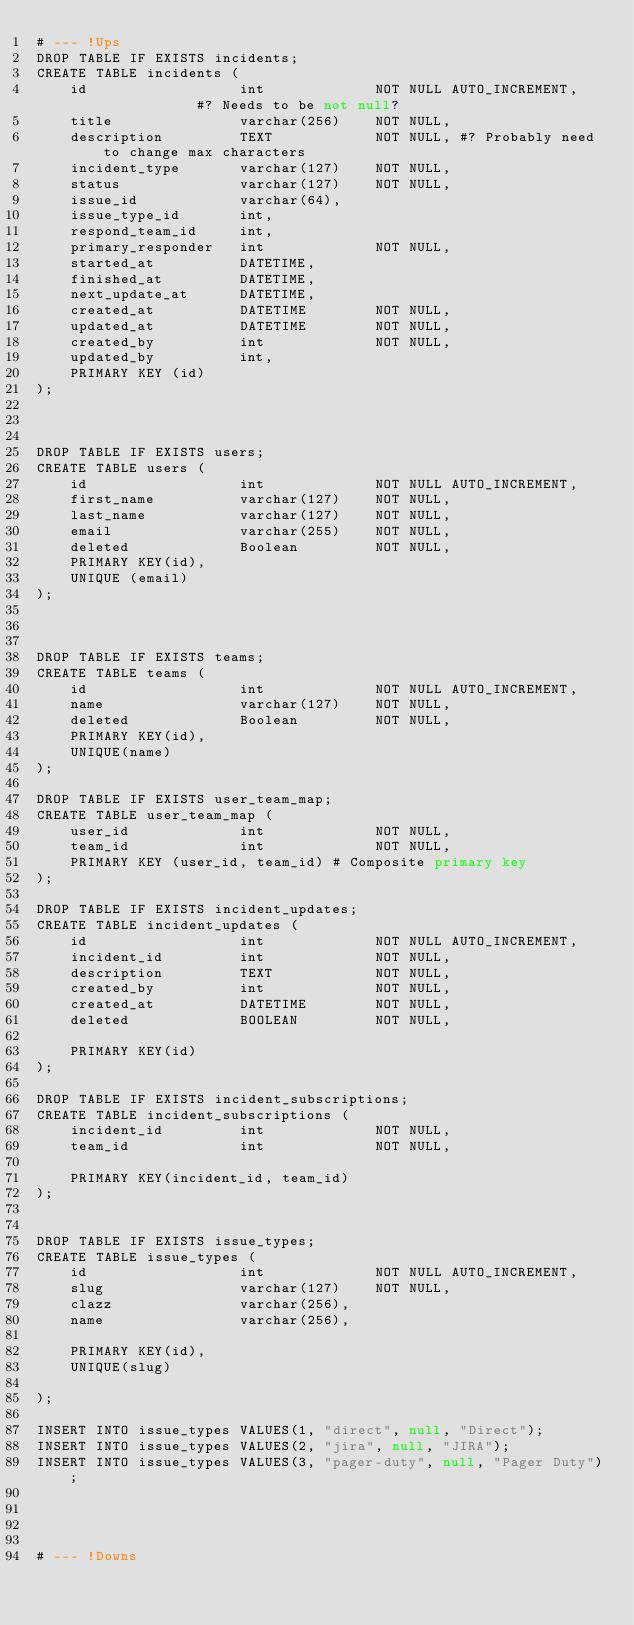<code> <loc_0><loc_0><loc_500><loc_500><_SQL_># --- !Ups
DROP TABLE IF EXISTS incidents;
CREATE TABLE incidents (
	id 					int 			NOT NULL AUTO_INCREMENT, 			#? Needs to be not null?
	title 				varchar(256)	NOT NULL,
	description 		TEXT			NOT NULL, #? Probably need to change max characters
	incident_type		varchar(127)	NOT NULL,
	status				varchar(127)	NOT NULL,
	issue_id			varchar(64),
	issue_type_id		int,	
	respond_team_id		int,
	primary_responder 	int   			NOT NULL,
	started_at			DATETIME,
	finished_at			DATETIME,
	next_update_at		DATETIME,
	created_at			DATETIME		NOT NULL,
	updated_at			DATETIME		NOT NULL,
	created_by			int 			NOT NULL,
	updated_by			int,
	PRIMARY KEY (id)
);



DROP TABLE IF EXISTS users;
CREATE TABLE users (
	id 					int           	NOT NULL AUTO_INCREMENT,
	first_name			varchar(127)	NOT NULL,
	last_name			varchar(127)	NOT NULL,
	email				varchar(255)	NOT NULL,
	deleted 			Boolean 		NOT NULL,
	PRIMARY KEY(id),
	UNIQUE (email)
);



DROP TABLE IF EXISTS teams;
CREATE TABLE teams (
	id 					int 			NOT NULL AUTO_INCREMENT,
	name 				varchar(127)	NOT NULL,
	deleted 			Boolean 		NOT NULL,
	PRIMARY KEY(id),
	UNIQUE(name)
);

DROP TABLE IF EXISTS user_team_map;
CREATE TABLE user_team_map (
	user_id				int 			NOT NULL,
	team_id  			int 			NOT NULL,
	PRIMARY KEY (user_id, team_id) # Composite primary key
);

DROP TABLE IF EXISTS incident_updates;
CREATE TABLE incident_updates (
	id  				int 			NOT NULL AUTO_INCREMENT,
	incident_id			int             NOT NULL,
	description			TEXT 			NOT NULL,
	created_by			int 			NOT NULL,
	created_at			DATETIME		NOT NULL,
	deleted				BOOLEAN 		NOT NULL,

	PRIMARY KEY(id)
);

DROP TABLE IF EXISTS incident_subscriptions;
CREATE TABLE incident_subscriptions (
	incident_id			int 			NOT NULL,
	team_id 			int 			NOT NULL,

	PRIMARY KEY(incident_id, team_id)
);


DROP TABLE IF EXISTS issue_types;
CREATE TABLE issue_types (
	id					int 			NOT NULL AUTO_INCREMENT,
	slug				varchar(127)	NOT NULL,
	clazz				varchar(256),
	name 				varchar(256),

	PRIMARY KEY(id),
	UNIQUE(slug)

);

INSERT INTO issue_types VALUES(1, "direct", null, "Direct");
INSERT INTO issue_types VALUES(2, "jira", null, "JIRA");
INSERT INTO issue_types VALUES(3, "pager-duty", null, "Pager Duty");




# --- !Downs</code> 